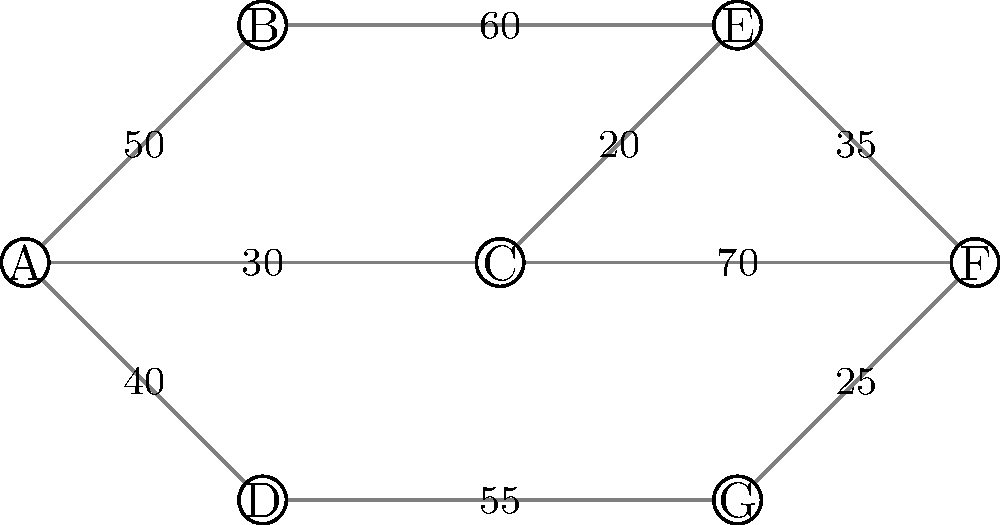In the given network diagram representing public transportation routes, nodes represent stations and edge weights represent the average number of passengers traveling between stations per hour. What is the minimum number of passengers that must be accommodated per hour to ensure all routes are operational, assuming each route requires at least one direction to have more than 45 passengers per hour to remain active? To solve this problem, we need to follow these steps:

1. Identify all routes (edges) in the network.
2. For each route, check if the passenger flow is greater than 45.
3. If a route has less than or equal to 45 passengers, we need to increase it to 46.
4. Sum up the additional passengers needed for all routes.

Let's analyze each route:

1. A-B: 50 > 45, no change needed
2. A-C: 30 < 45, needs 16 more passengers
3. A-D: 40 < 45, needs 6 more passengers
4. B-E: 60 > 45, no change needed
5. C-E: 20 < 45, needs 26 more passengers
6. C-F: 70 > 45, no change needed
7. D-G: 55 > 45, no change needed
8. E-F: 35 < 45, needs 11 more passengers
9. F-G: 25 < 45, needs 21 more passengers

Now, we sum up the additional passengers needed:
16 + 6 + 26 + 11 + 21 = 80

Therefore, a minimum of 80 additional passengers per hour must be accommodated to ensure all routes remain operational.
Answer: 80 passengers 